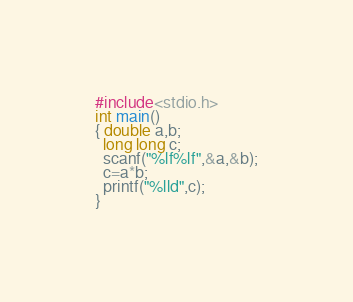<code> <loc_0><loc_0><loc_500><loc_500><_C_>#include<stdio.h>
int main()
{ double a,b;
  long long c;
  scanf("%lf%lf",&a,&b);
  c=a*b;
  printf("%lld",c);
} </code> 